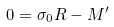Convert formula to latex. <formula><loc_0><loc_0><loc_500><loc_500>0 = { \sigma } _ { 0 } R - M ^ { \prime }</formula> 